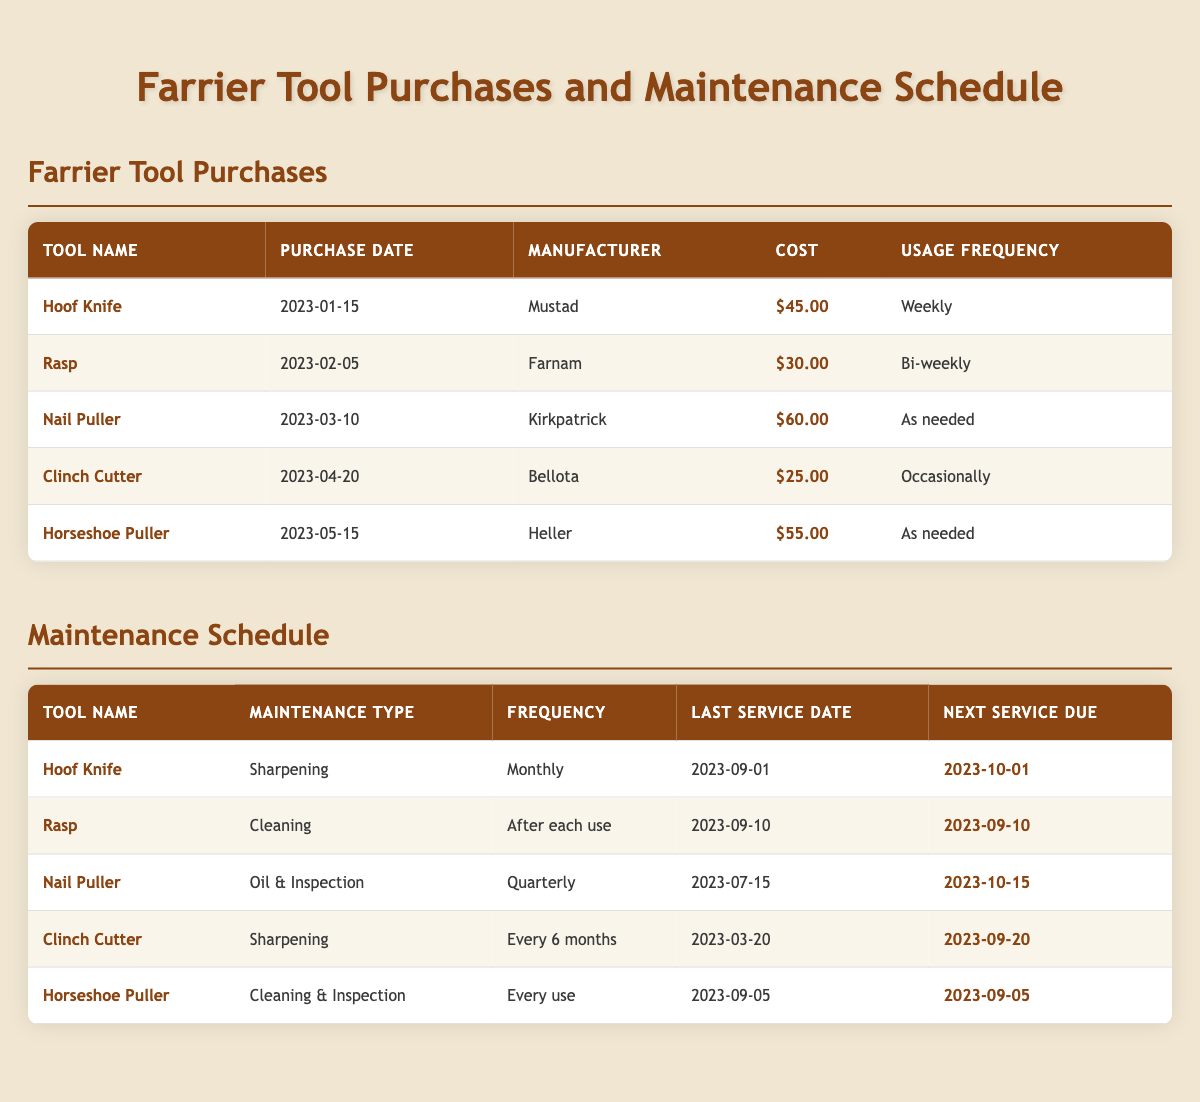What is the purchase cost of the Hoof Knife? The table shows that the cost for the Hoof Knife is listed as $45.00. Therefore, the purchase cost is directly retrievable from the table.
Answer: $45.00 Which tool has the highest purchase cost? Comparing the costs from the table, the Nail Puller is priced at $60.00, which is higher than the prices of the other tools.
Answer: Nail Puller How often should the Rasp be cleaned? The Rasp has a maintenance frequency of "After each use" according to the maintenance schedule provided in the table.
Answer: After each use What was the last service date for the Clinch Cutter? The last service date for the Clinch Cutter can be found in the maintenance schedule, which states it was last serviced on 2023-03-20.
Answer: 2023-03-20 What is the next service due for the Hoof Knife? The table indicates that the next service due for the Hoof Knife is 2023-10-01, as specified in the maintenance schedule.
Answer: 2023-10-01 How much did the average tool cost? To find the average cost, sum the costs of all tools ($45.00 + $30.00 + $60.00 + $25.00 + $55.00 = $215.00) and divide by the number of tools (5), which gives $215.00 / 5 = $43.00.
Answer: $43.00 Is there any tool that requires maintenance after every use? Yes, the Horseshoe Puller requires "Cleaning & Inspection" with a frequency of "Every use," as indicated in the maintenance schedule.
Answer: Yes Which tools require sharpening and how frequently? The Hoof Knife requires sharpening monthly, and the Clinch Cutter requires sharpening every 6 months. This can be verified from the maintenance section of the table.
Answer: Hoof Knife (Monthly), Clinch Cutter (Every 6 months) When is the next service due for the Nail Puller? The next service due for the Nail Puller, according to the maintenance schedule, is on 2023-10-15. This date is listed directly in the table.
Answer: 2023-10-15 Which two tools have maintenance frequencies that are specified to be "As needed"? The Nail Puller and the Horseshoe Puller are both listed under the usage frequency "As needed," according to the farrier tool purchases section of the table.
Answer: Nail Puller, Horseshoe Puller 